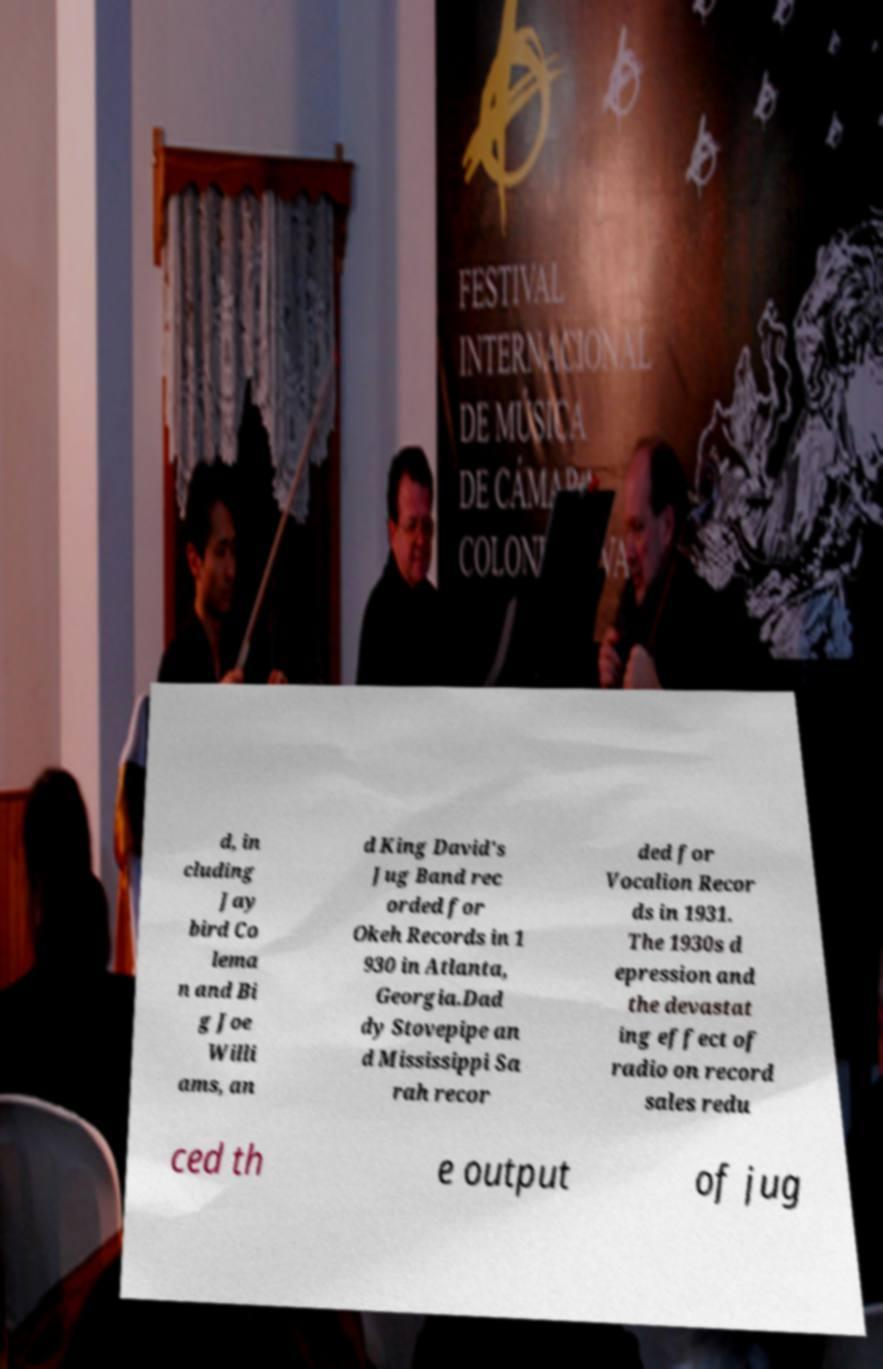Please read and relay the text visible in this image. What does it say? d, in cluding Jay bird Co lema n and Bi g Joe Willi ams, an d King David's Jug Band rec orded for Okeh Records in 1 930 in Atlanta, Georgia.Dad dy Stovepipe an d Mississippi Sa rah recor ded for Vocalion Recor ds in 1931. The 1930s d epression and the devastat ing effect of radio on record sales redu ced th e output of jug 